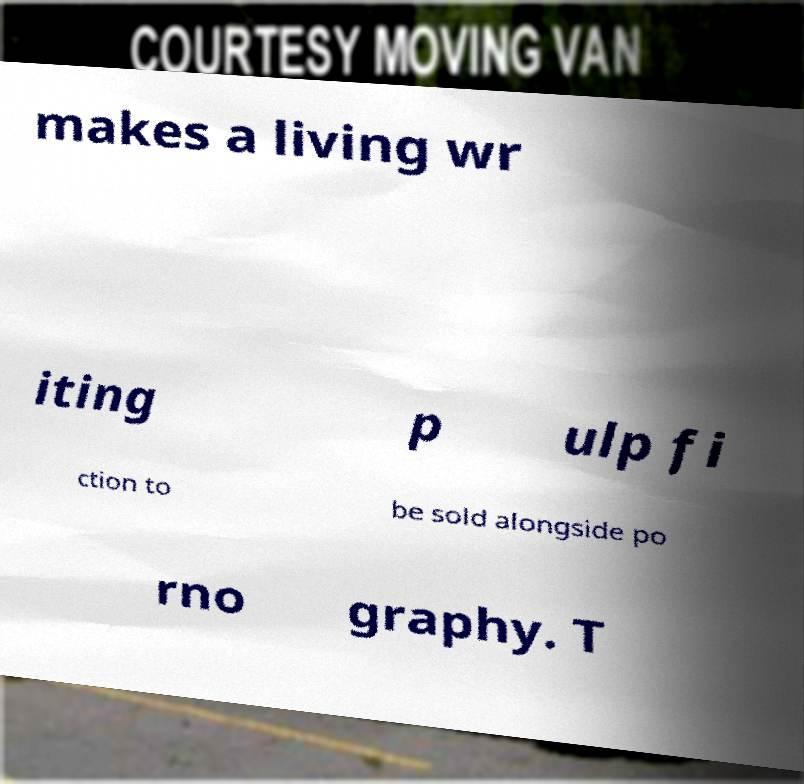For documentation purposes, I need the text within this image transcribed. Could you provide that? makes a living wr iting p ulp fi ction to be sold alongside po rno graphy. T 